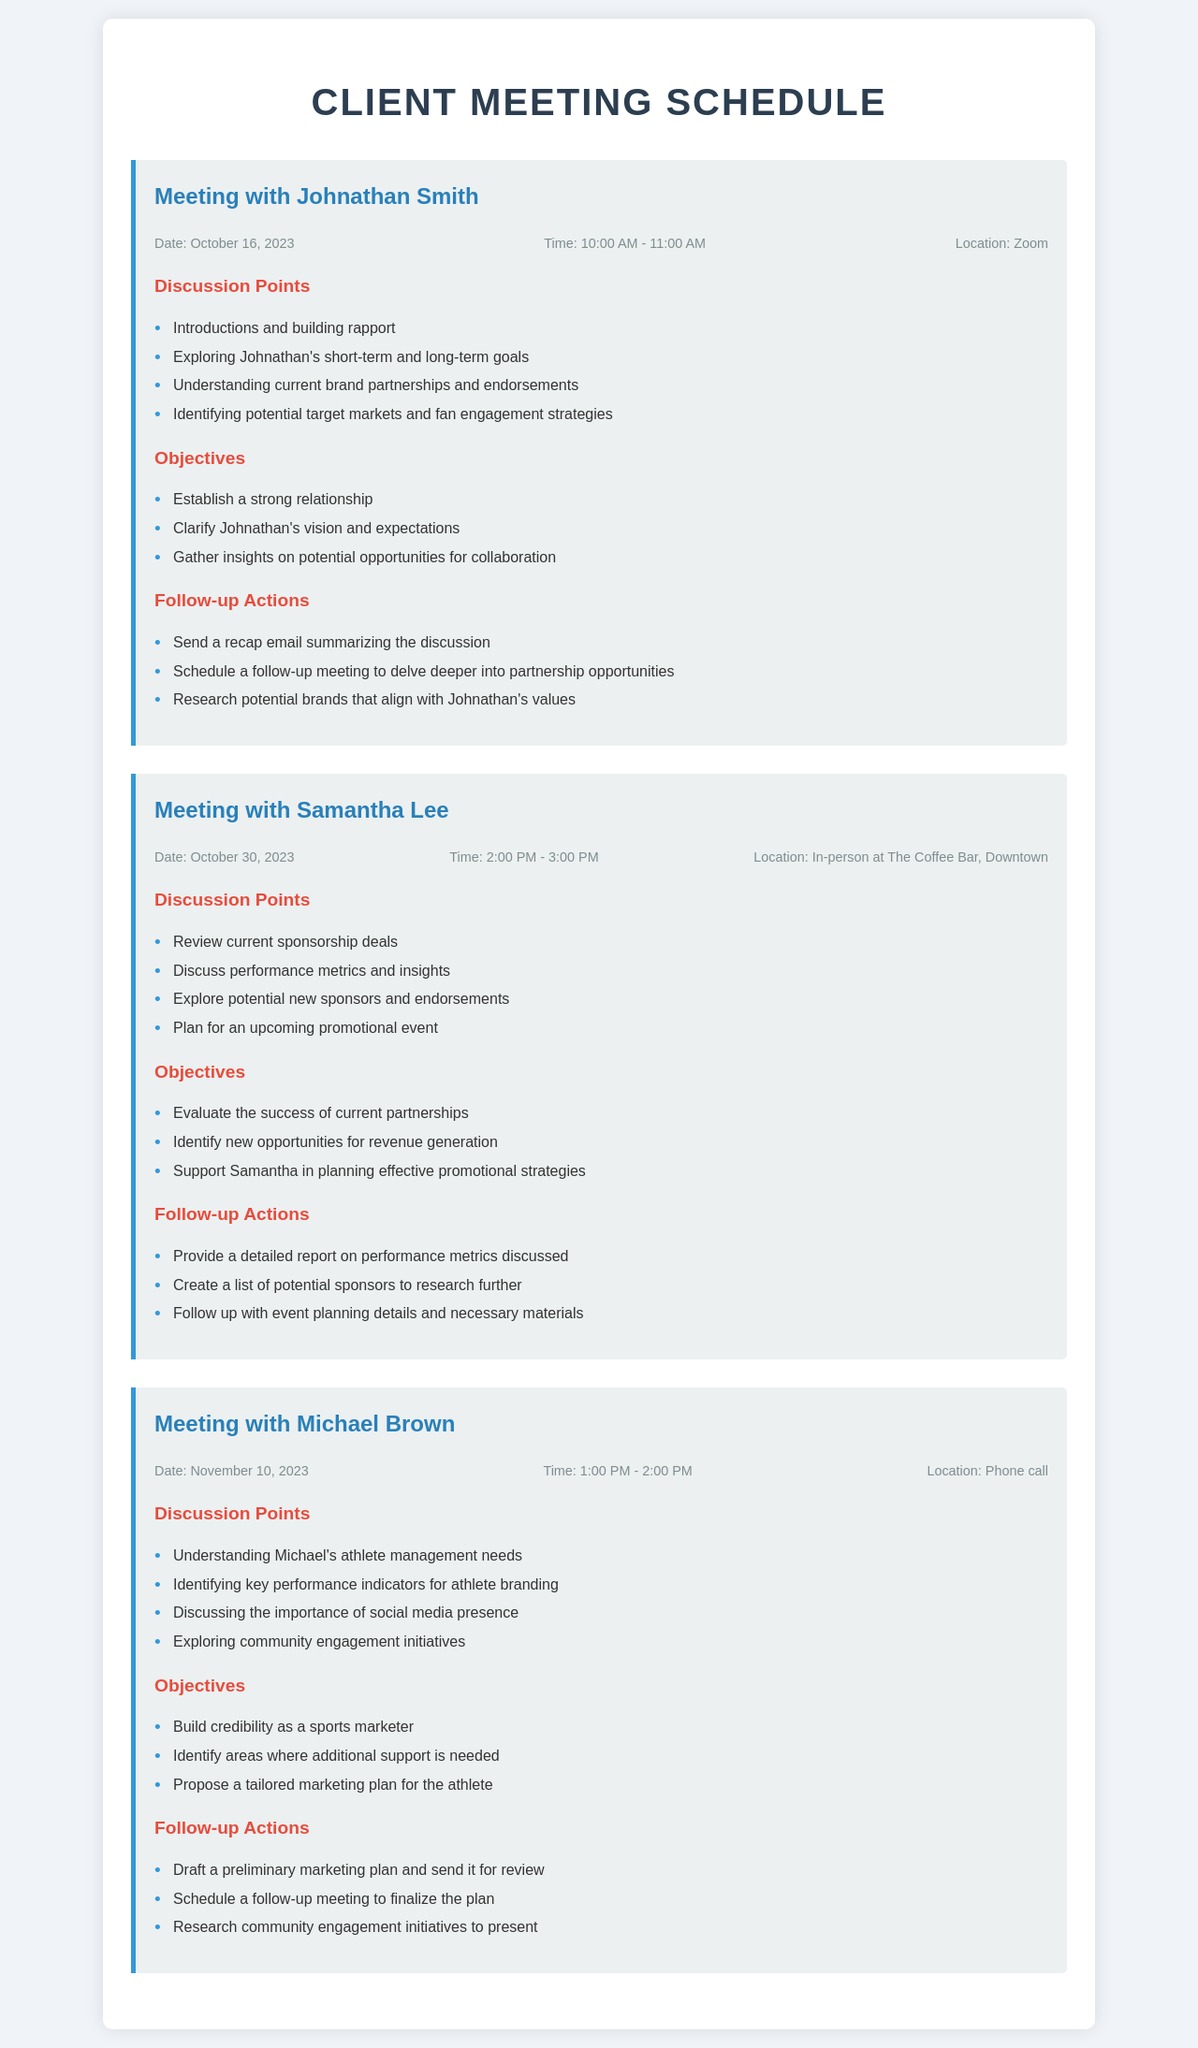What is the date of the meeting with Johnathan Smith? The date is explicitly mentioned in the meeting section for Johnathan Smith.
Answer: October 16, 2023 What is the time for the meeting with Samantha Lee? The time is specified in the meeting info section for Samantha Lee.
Answer: 2:00 PM - 3:00 PM Where is the meeting with Michael Brown being held? The location is indicated in the meeting info for Michael Brown.
Answer: Phone call What is one objective of the meeting with Johnathan Smith? The objectives are listed, and any one of them can be chosen; for example, the first objective is highlighted.
Answer: Establish a strong relationship Name one follow-up action from the meeting with Samantha Lee. Follow-up actions are outlined, and one can be selected from the list.
Answer: Provide a detailed report on performance metrics discussed What performance aspect will be discussed in the meeting with Michael Brown? The discussion points outline various aspects, and one relevant point can be referenced.
Answer: Key performance indicators for athlete branding How many meetings are scheduled in the document? The total count of meetings can be deduced from the document.
Answer: 3 What is the main discussion point for the meeting with Samantha Lee? The discussion points are stated, and the first one can be noted as a primary focus.
Answer: Review current sponsorship deals What day of the week is the meeting with Johnathan Smith? The date can be checked and the day of the week calculated based on the calendar.
Answer: Monday 